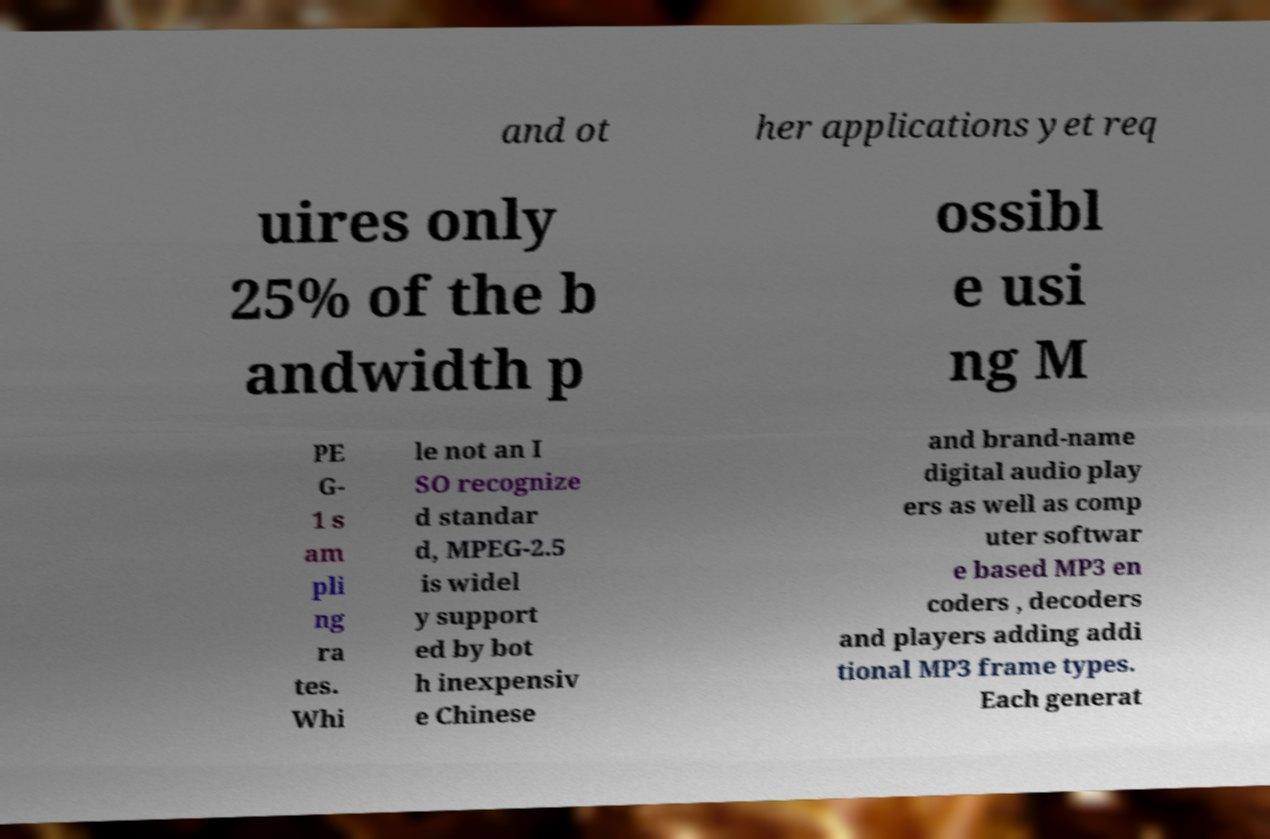Please identify and transcribe the text found in this image. and ot her applications yet req uires only 25% of the b andwidth p ossibl e usi ng M PE G- 1 s am pli ng ra tes. Whi le not an I SO recognize d standar d, MPEG-2.5 is widel y support ed by bot h inexpensiv e Chinese and brand-name digital audio play ers as well as comp uter softwar e based MP3 en coders , decoders and players adding addi tional MP3 frame types. Each generat 